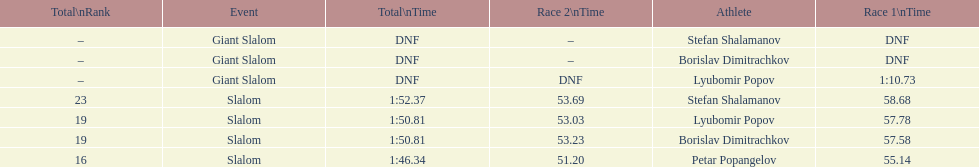Who came after borislav dimitrachkov and it's time for slalom Petar Popangelov. Can you give me this table as a dict? {'header': ['Total\\nRank', 'Event', 'Total\\nTime', 'Race 2\\nTime', 'Athlete', 'Race 1\\nTime'], 'rows': [['–', 'Giant Slalom', 'DNF', '–', 'Stefan Shalamanov', 'DNF'], ['–', 'Giant Slalom', 'DNF', '–', 'Borislav Dimitrachkov', 'DNF'], ['–', 'Giant Slalom', 'DNF', 'DNF', 'Lyubomir Popov', '1:10.73'], ['23', 'Slalom', '1:52.37', '53.69', 'Stefan Shalamanov', '58.68'], ['19', 'Slalom', '1:50.81', '53.03', 'Lyubomir Popov', '57.78'], ['19', 'Slalom', '1:50.81', '53.23', 'Borislav Dimitrachkov', '57.58'], ['16', 'Slalom', '1:46.34', '51.20', 'Petar Popangelov', '55.14']]} 